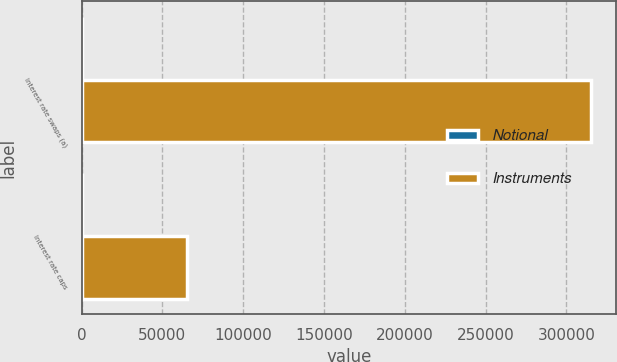<chart> <loc_0><loc_0><loc_500><loc_500><stacked_bar_chart><ecel><fcel>Interest rate swaps (a)<fcel>Interest rate caps<nl><fcel>Notional<fcel>4<fcel>1<nl><fcel>Instruments<fcel>315000<fcel>65197<nl></chart> 